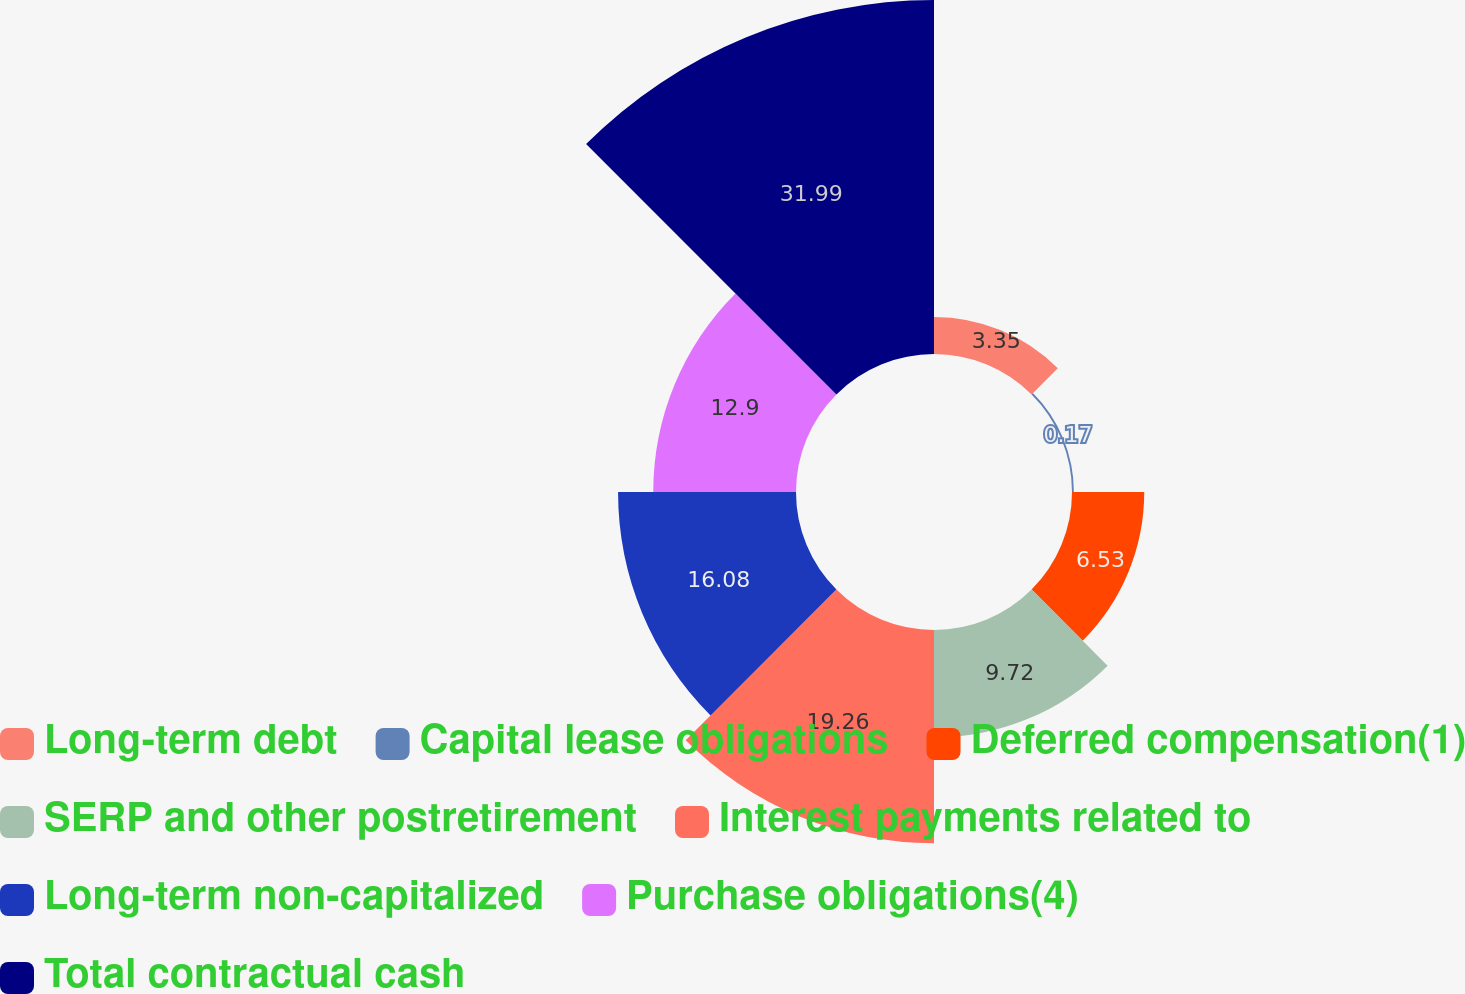Convert chart. <chart><loc_0><loc_0><loc_500><loc_500><pie_chart><fcel>Long-term debt<fcel>Capital lease obligations<fcel>Deferred compensation(1)<fcel>SERP and other postretirement<fcel>Interest payments related to<fcel>Long-term non-capitalized<fcel>Purchase obligations(4)<fcel>Total contractual cash<nl><fcel>3.35%<fcel>0.17%<fcel>6.53%<fcel>9.72%<fcel>19.26%<fcel>16.08%<fcel>12.9%<fcel>31.99%<nl></chart> 